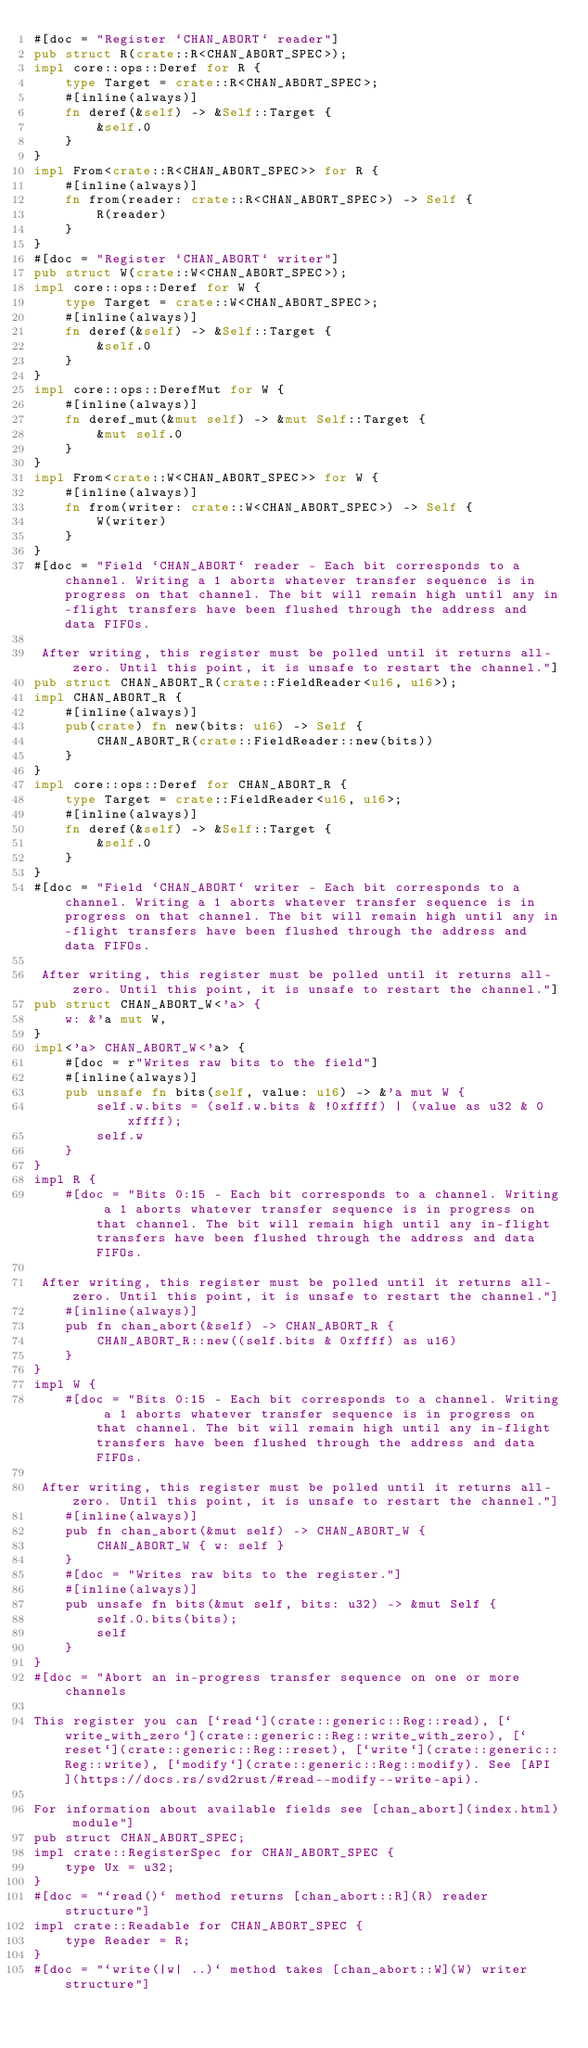<code> <loc_0><loc_0><loc_500><loc_500><_Rust_>#[doc = "Register `CHAN_ABORT` reader"]
pub struct R(crate::R<CHAN_ABORT_SPEC>);
impl core::ops::Deref for R {
    type Target = crate::R<CHAN_ABORT_SPEC>;
    #[inline(always)]
    fn deref(&self) -> &Self::Target {
        &self.0
    }
}
impl From<crate::R<CHAN_ABORT_SPEC>> for R {
    #[inline(always)]
    fn from(reader: crate::R<CHAN_ABORT_SPEC>) -> Self {
        R(reader)
    }
}
#[doc = "Register `CHAN_ABORT` writer"]
pub struct W(crate::W<CHAN_ABORT_SPEC>);
impl core::ops::Deref for W {
    type Target = crate::W<CHAN_ABORT_SPEC>;
    #[inline(always)]
    fn deref(&self) -> &Self::Target {
        &self.0
    }
}
impl core::ops::DerefMut for W {
    #[inline(always)]
    fn deref_mut(&mut self) -> &mut Self::Target {
        &mut self.0
    }
}
impl From<crate::W<CHAN_ABORT_SPEC>> for W {
    #[inline(always)]
    fn from(writer: crate::W<CHAN_ABORT_SPEC>) -> Self {
        W(writer)
    }
}
#[doc = "Field `CHAN_ABORT` reader - Each bit corresponds to a channel. Writing a 1 aborts whatever transfer sequence is in progress on that channel. The bit will remain high until any in-flight transfers have been flushed through the address and data FIFOs.  

 After writing, this register must be polled until it returns all-zero. Until this point, it is unsafe to restart the channel."]
pub struct CHAN_ABORT_R(crate::FieldReader<u16, u16>);
impl CHAN_ABORT_R {
    #[inline(always)]
    pub(crate) fn new(bits: u16) -> Self {
        CHAN_ABORT_R(crate::FieldReader::new(bits))
    }
}
impl core::ops::Deref for CHAN_ABORT_R {
    type Target = crate::FieldReader<u16, u16>;
    #[inline(always)]
    fn deref(&self) -> &Self::Target {
        &self.0
    }
}
#[doc = "Field `CHAN_ABORT` writer - Each bit corresponds to a channel. Writing a 1 aborts whatever transfer sequence is in progress on that channel. The bit will remain high until any in-flight transfers have been flushed through the address and data FIFOs.  

 After writing, this register must be polled until it returns all-zero. Until this point, it is unsafe to restart the channel."]
pub struct CHAN_ABORT_W<'a> {
    w: &'a mut W,
}
impl<'a> CHAN_ABORT_W<'a> {
    #[doc = r"Writes raw bits to the field"]
    #[inline(always)]
    pub unsafe fn bits(self, value: u16) -> &'a mut W {
        self.w.bits = (self.w.bits & !0xffff) | (value as u32 & 0xffff);
        self.w
    }
}
impl R {
    #[doc = "Bits 0:15 - Each bit corresponds to a channel. Writing a 1 aborts whatever transfer sequence is in progress on that channel. The bit will remain high until any in-flight transfers have been flushed through the address and data FIFOs.  

 After writing, this register must be polled until it returns all-zero. Until this point, it is unsafe to restart the channel."]
    #[inline(always)]
    pub fn chan_abort(&self) -> CHAN_ABORT_R {
        CHAN_ABORT_R::new((self.bits & 0xffff) as u16)
    }
}
impl W {
    #[doc = "Bits 0:15 - Each bit corresponds to a channel. Writing a 1 aborts whatever transfer sequence is in progress on that channel. The bit will remain high until any in-flight transfers have been flushed through the address and data FIFOs.  

 After writing, this register must be polled until it returns all-zero. Until this point, it is unsafe to restart the channel."]
    #[inline(always)]
    pub fn chan_abort(&mut self) -> CHAN_ABORT_W {
        CHAN_ABORT_W { w: self }
    }
    #[doc = "Writes raw bits to the register."]
    #[inline(always)]
    pub unsafe fn bits(&mut self, bits: u32) -> &mut Self {
        self.0.bits(bits);
        self
    }
}
#[doc = "Abort an in-progress transfer sequence on one or more channels  

This register you can [`read`](crate::generic::Reg::read), [`write_with_zero`](crate::generic::Reg::write_with_zero), [`reset`](crate::generic::Reg::reset), [`write`](crate::generic::Reg::write), [`modify`](crate::generic::Reg::modify). See [API](https://docs.rs/svd2rust/#read--modify--write-api).  

For information about available fields see [chan_abort](index.html) module"]
pub struct CHAN_ABORT_SPEC;
impl crate::RegisterSpec for CHAN_ABORT_SPEC {
    type Ux = u32;
}
#[doc = "`read()` method returns [chan_abort::R](R) reader structure"]
impl crate::Readable for CHAN_ABORT_SPEC {
    type Reader = R;
}
#[doc = "`write(|w| ..)` method takes [chan_abort::W](W) writer structure"]</code> 